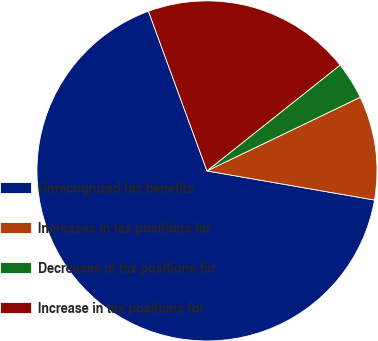Convert chart to OTSL. <chart><loc_0><loc_0><loc_500><loc_500><pie_chart><fcel>Unrecognized tax benefits<fcel>Increases in tax positions for<fcel>Decreases in tax positions for<fcel>Increase in tax positions for<nl><fcel>66.66%<fcel>9.87%<fcel>3.56%<fcel>19.9%<nl></chart> 